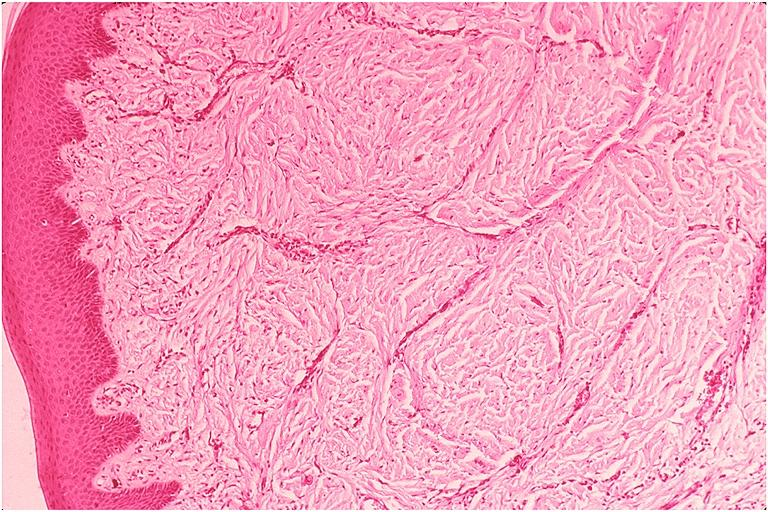does this image show epulis fissuratum?
Answer the question using a single word or phrase. Yes 